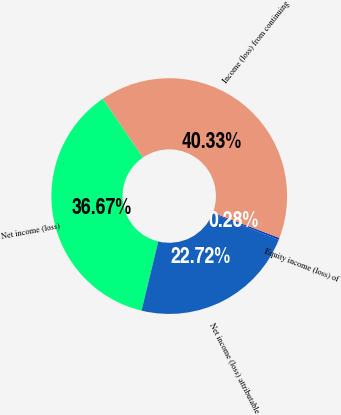<chart> <loc_0><loc_0><loc_500><loc_500><pie_chart><fcel>Equity income (loss) of<fcel>Income (loss) from continuing<fcel>Net income (loss)<fcel>Net income (loss) attributable<nl><fcel>0.28%<fcel>40.33%<fcel>36.67%<fcel>22.72%<nl></chart> 